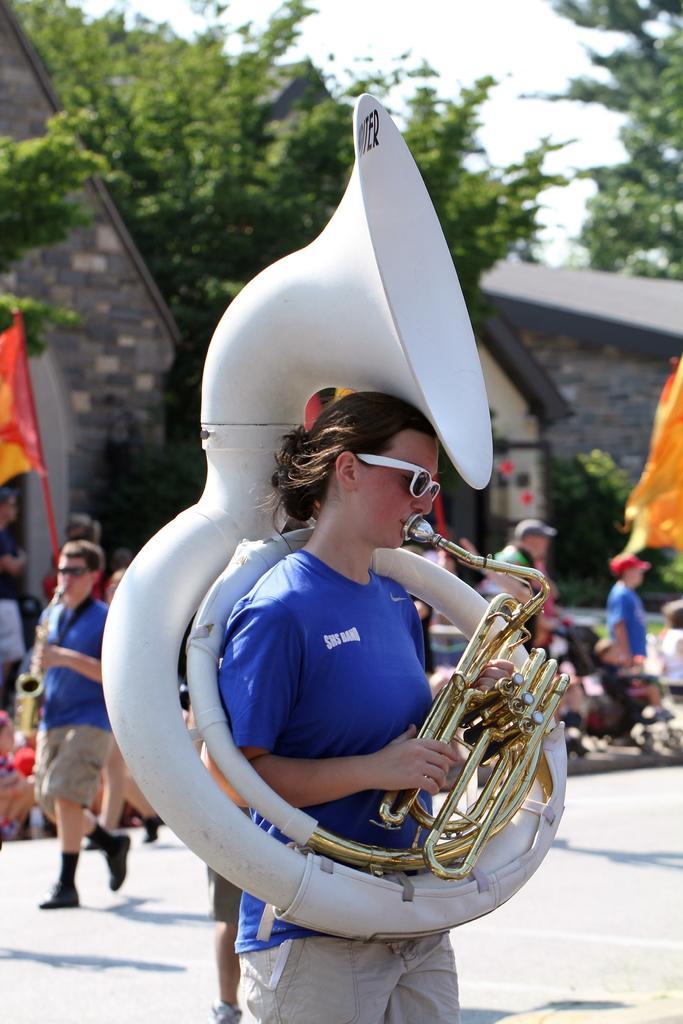Please provide a concise description of this image. In the center of the image a lady is standing and holding a musical instrument. In the background of the image we can see houses, trees and some persons, flag are there. At the bottom of the image ground is present. At the top of the image sky is there. 